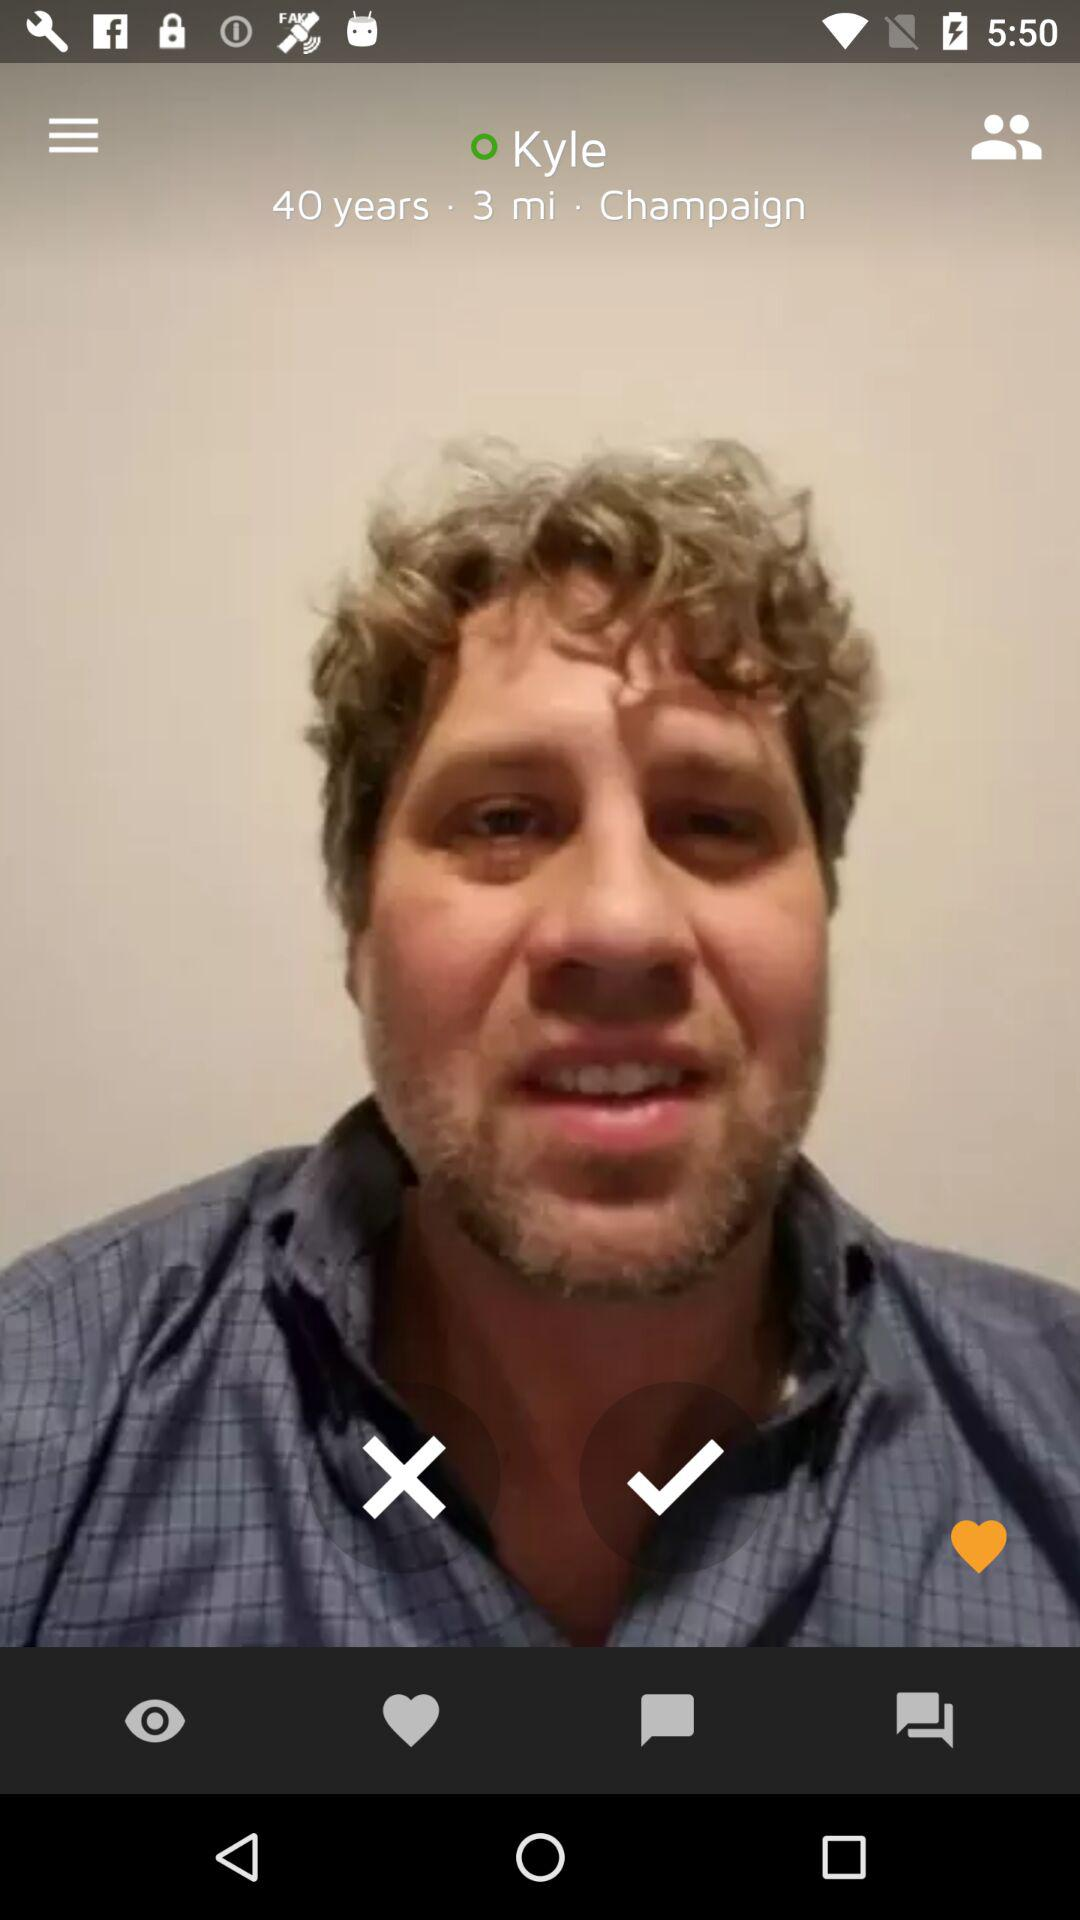What is the age? The age is 40 years. 